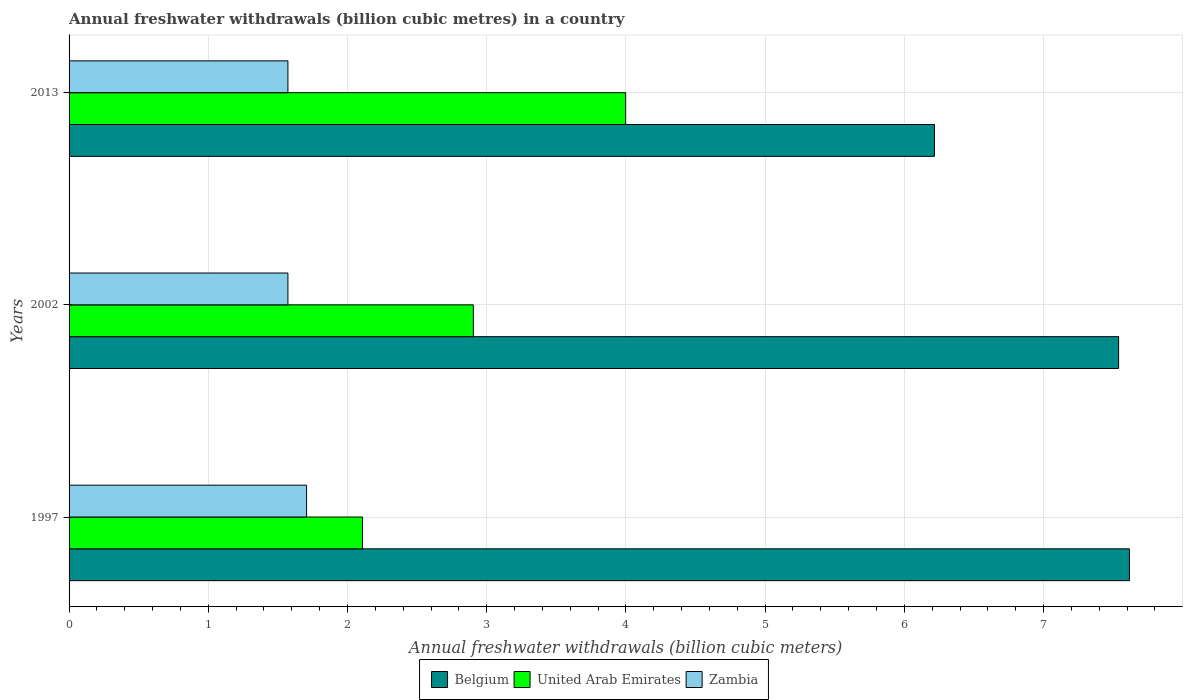How many groups of bars are there?
Make the answer very short. 3. How many bars are there on the 1st tick from the top?
Ensure brevity in your answer.  3. How many bars are there on the 2nd tick from the bottom?
Provide a short and direct response. 3. What is the label of the 1st group of bars from the top?
Ensure brevity in your answer.  2013. In how many cases, is the number of bars for a given year not equal to the number of legend labels?
Provide a short and direct response. 0. What is the annual freshwater withdrawals in United Arab Emirates in 2013?
Offer a terse response. 4. Across all years, what is the maximum annual freshwater withdrawals in Zambia?
Make the answer very short. 1.71. Across all years, what is the minimum annual freshwater withdrawals in Zambia?
Make the answer very short. 1.57. What is the total annual freshwater withdrawals in Zambia in the graph?
Make the answer very short. 4.85. What is the difference between the annual freshwater withdrawals in United Arab Emirates in 1997 and that in 2013?
Ensure brevity in your answer.  -1.89. What is the difference between the annual freshwater withdrawals in United Arab Emirates in 1997 and the annual freshwater withdrawals in Belgium in 2002?
Your response must be concise. -5.43. What is the average annual freshwater withdrawals in Zambia per year?
Offer a very short reply. 1.62. In the year 1997, what is the difference between the annual freshwater withdrawals in Zambia and annual freshwater withdrawals in United Arab Emirates?
Provide a succinct answer. -0.4. In how many years, is the annual freshwater withdrawals in Belgium greater than 2.2 billion cubic meters?
Ensure brevity in your answer.  3. What is the ratio of the annual freshwater withdrawals in Zambia in 2002 to that in 2013?
Offer a terse response. 1. Is the difference between the annual freshwater withdrawals in Zambia in 2002 and 2013 greater than the difference between the annual freshwater withdrawals in United Arab Emirates in 2002 and 2013?
Offer a very short reply. Yes. What is the difference between the highest and the second highest annual freshwater withdrawals in United Arab Emirates?
Offer a terse response. 1.09. What is the difference between the highest and the lowest annual freshwater withdrawals in Zambia?
Make the answer very short. 0.13. In how many years, is the annual freshwater withdrawals in Zambia greater than the average annual freshwater withdrawals in Zambia taken over all years?
Your response must be concise. 1. Is the sum of the annual freshwater withdrawals in Zambia in 1997 and 2002 greater than the maximum annual freshwater withdrawals in United Arab Emirates across all years?
Give a very brief answer. No. What does the 1st bar from the top in 1997 represents?
Make the answer very short. Zambia. What does the 1st bar from the bottom in 1997 represents?
Your answer should be very brief. Belgium. Is it the case that in every year, the sum of the annual freshwater withdrawals in Zambia and annual freshwater withdrawals in Belgium is greater than the annual freshwater withdrawals in United Arab Emirates?
Keep it short and to the point. Yes. How many bars are there?
Your response must be concise. 9. Where does the legend appear in the graph?
Your answer should be very brief. Bottom center. What is the title of the graph?
Provide a short and direct response. Annual freshwater withdrawals (billion cubic metres) in a country. What is the label or title of the X-axis?
Your answer should be very brief. Annual freshwater withdrawals (billion cubic meters). What is the Annual freshwater withdrawals (billion cubic meters) in Belgium in 1997?
Your response must be concise. 7.62. What is the Annual freshwater withdrawals (billion cubic meters) in United Arab Emirates in 1997?
Make the answer very short. 2.11. What is the Annual freshwater withdrawals (billion cubic meters) of Zambia in 1997?
Offer a terse response. 1.71. What is the Annual freshwater withdrawals (billion cubic meters) in Belgium in 2002?
Provide a short and direct response. 7.54. What is the Annual freshwater withdrawals (billion cubic meters) of United Arab Emirates in 2002?
Offer a very short reply. 2.9. What is the Annual freshwater withdrawals (billion cubic meters) of Zambia in 2002?
Keep it short and to the point. 1.57. What is the Annual freshwater withdrawals (billion cubic meters) of Belgium in 2013?
Offer a terse response. 6.22. What is the Annual freshwater withdrawals (billion cubic meters) of United Arab Emirates in 2013?
Offer a terse response. 4. What is the Annual freshwater withdrawals (billion cubic meters) of Zambia in 2013?
Give a very brief answer. 1.57. Across all years, what is the maximum Annual freshwater withdrawals (billion cubic meters) in Belgium?
Provide a short and direct response. 7.62. Across all years, what is the maximum Annual freshwater withdrawals (billion cubic meters) in United Arab Emirates?
Ensure brevity in your answer.  4. Across all years, what is the maximum Annual freshwater withdrawals (billion cubic meters) of Zambia?
Ensure brevity in your answer.  1.71. Across all years, what is the minimum Annual freshwater withdrawals (billion cubic meters) of Belgium?
Offer a very short reply. 6.22. Across all years, what is the minimum Annual freshwater withdrawals (billion cubic meters) in United Arab Emirates?
Give a very brief answer. 2.11. Across all years, what is the minimum Annual freshwater withdrawals (billion cubic meters) of Zambia?
Offer a terse response. 1.57. What is the total Annual freshwater withdrawals (billion cubic meters) of Belgium in the graph?
Your answer should be compact. 21.37. What is the total Annual freshwater withdrawals (billion cubic meters) in United Arab Emirates in the graph?
Keep it short and to the point. 9.01. What is the total Annual freshwater withdrawals (billion cubic meters) in Zambia in the graph?
Provide a succinct answer. 4.85. What is the difference between the Annual freshwater withdrawals (billion cubic meters) of Belgium in 1997 and that in 2002?
Make the answer very short. 0.08. What is the difference between the Annual freshwater withdrawals (billion cubic meters) of United Arab Emirates in 1997 and that in 2002?
Your answer should be very brief. -0.8. What is the difference between the Annual freshwater withdrawals (billion cubic meters) of Zambia in 1997 and that in 2002?
Provide a short and direct response. 0.13. What is the difference between the Annual freshwater withdrawals (billion cubic meters) of Belgium in 1997 and that in 2013?
Offer a very short reply. 1.4. What is the difference between the Annual freshwater withdrawals (billion cubic meters) in United Arab Emirates in 1997 and that in 2013?
Provide a short and direct response. -1.89. What is the difference between the Annual freshwater withdrawals (billion cubic meters) of Zambia in 1997 and that in 2013?
Provide a succinct answer. 0.13. What is the difference between the Annual freshwater withdrawals (billion cubic meters) in Belgium in 2002 and that in 2013?
Provide a short and direct response. 1.32. What is the difference between the Annual freshwater withdrawals (billion cubic meters) of United Arab Emirates in 2002 and that in 2013?
Make the answer very short. -1.09. What is the difference between the Annual freshwater withdrawals (billion cubic meters) in Zambia in 2002 and that in 2013?
Your answer should be compact. 0. What is the difference between the Annual freshwater withdrawals (billion cubic meters) of Belgium in 1997 and the Annual freshwater withdrawals (billion cubic meters) of United Arab Emirates in 2002?
Keep it short and to the point. 4.71. What is the difference between the Annual freshwater withdrawals (billion cubic meters) of Belgium in 1997 and the Annual freshwater withdrawals (billion cubic meters) of Zambia in 2002?
Offer a very short reply. 6.04. What is the difference between the Annual freshwater withdrawals (billion cubic meters) in United Arab Emirates in 1997 and the Annual freshwater withdrawals (billion cubic meters) in Zambia in 2002?
Keep it short and to the point. 0.54. What is the difference between the Annual freshwater withdrawals (billion cubic meters) of Belgium in 1997 and the Annual freshwater withdrawals (billion cubic meters) of United Arab Emirates in 2013?
Provide a short and direct response. 3.62. What is the difference between the Annual freshwater withdrawals (billion cubic meters) in Belgium in 1997 and the Annual freshwater withdrawals (billion cubic meters) in Zambia in 2013?
Ensure brevity in your answer.  6.04. What is the difference between the Annual freshwater withdrawals (billion cubic meters) of United Arab Emirates in 1997 and the Annual freshwater withdrawals (billion cubic meters) of Zambia in 2013?
Ensure brevity in your answer.  0.54. What is the difference between the Annual freshwater withdrawals (billion cubic meters) in Belgium in 2002 and the Annual freshwater withdrawals (billion cubic meters) in United Arab Emirates in 2013?
Make the answer very short. 3.54. What is the difference between the Annual freshwater withdrawals (billion cubic meters) of Belgium in 2002 and the Annual freshwater withdrawals (billion cubic meters) of Zambia in 2013?
Provide a short and direct response. 5.97. What is the difference between the Annual freshwater withdrawals (billion cubic meters) of United Arab Emirates in 2002 and the Annual freshwater withdrawals (billion cubic meters) of Zambia in 2013?
Provide a succinct answer. 1.33. What is the average Annual freshwater withdrawals (billion cubic meters) of Belgium per year?
Ensure brevity in your answer.  7.12. What is the average Annual freshwater withdrawals (billion cubic meters) in United Arab Emirates per year?
Your answer should be very brief. 3. What is the average Annual freshwater withdrawals (billion cubic meters) of Zambia per year?
Make the answer very short. 1.62. In the year 1997, what is the difference between the Annual freshwater withdrawals (billion cubic meters) in Belgium and Annual freshwater withdrawals (billion cubic meters) in United Arab Emirates?
Offer a very short reply. 5.51. In the year 1997, what is the difference between the Annual freshwater withdrawals (billion cubic meters) in Belgium and Annual freshwater withdrawals (billion cubic meters) in Zambia?
Offer a terse response. 5.91. In the year 1997, what is the difference between the Annual freshwater withdrawals (billion cubic meters) of United Arab Emirates and Annual freshwater withdrawals (billion cubic meters) of Zambia?
Ensure brevity in your answer.  0.4. In the year 2002, what is the difference between the Annual freshwater withdrawals (billion cubic meters) in Belgium and Annual freshwater withdrawals (billion cubic meters) in United Arab Emirates?
Give a very brief answer. 4.63. In the year 2002, what is the difference between the Annual freshwater withdrawals (billion cubic meters) in Belgium and Annual freshwater withdrawals (billion cubic meters) in Zambia?
Your response must be concise. 5.97. In the year 2002, what is the difference between the Annual freshwater withdrawals (billion cubic meters) in United Arab Emirates and Annual freshwater withdrawals (billion cubic meters) in Zambia?
Give a very brief answer. 1.33. In the year 2013, what is the difference between the Annual freshwater withdrawals (billion cubic meters) in Belgium and Annual freshwater withdrawals (billion cubic meters) in United Arab Emirates?
Your response must be concise. 2.22. In the year 2013, what is the difference between the Annual freshwater withdrawals (billion cubic meters) of Belgium and Annual freshwater withdrawals (billion cubic meters) of Zambia?
Your answer should be compact. 4.64. In the year 2013, what is the difference between the Annual freshwater withdrawals (billion cubic meters) of United Arab Emirates and Annual freshwater withdrawals (billion cubic meters) of Zambia?
Offer a very short reply. 2.43. What is the ratio of the Annual freshwater withdrawals (billion cubic meters) in Belgium in 1997 to that in 2002?
Provide a succinct answer. 1.01. What is the ratio of the Annual freshwater withdrawals (billion cubic meters) of United Arab Emirates in 1997 to that in 2002?
Provide a short and direct response. 0.73. What is the ratio of the Annual freshwater withdrawals (billion cubic meters) of Zambia in 1997 to that in 2002?
Provide a short and direct response. 1.09. What is the ratio of the Annual freshwater withdrawals (billion cubic meters) of Belgium in 1997 to that in 2013?
Provide a succinct answer. 1.23. What is the ratio of the Annual freshwater withdrawals (billion cubic meters) in United Arab Emirates in 1997 to that in 2013?
Give a very brief answer. 0.53. What is the ratio of the Annual freshwater withdrawals (billion cubic meters) in Zambia in 1997 to that in 2013?
Provide a short and direct response. 1.09. What is the ratio of the Annual freshwater withdrawals (billion cubic meters) in Belgium in 2002 to that in 2013?
Offer a terse response. 1.21. What is the ratio of the Annual freshwater withdrawals (billion cubic meters) of United Arab Emirates in 2002 to that in 2013?
Ensure brevity in your answer.  0.73. What is the difference between the highest and the second highest Annual freshwater withdrawals (billion cubic meters) in Belgium?
Your response must be concise. 0.08. What is the difference between the highest and the second highest Annual freshwater withdrawals (billion cubic meters) of United Arab Emirates?
Ensure brevity in your answer.  1.09. What is the difference between the highest and the second highest Annual freshwater withdrawals (billion cubic meters) in Zambia?
Your answer should be compact. 0.13. What is the difference between the highest and the lowest Annual freshwater withdrawals (billion cubic meters) in Belgium?
Give a very brief answer. 1.4. What is the difference between the highest and the lowest Annual freshwater withdrawals (billion cubic meters) of United Arab Emirates?
Ensure brevity in your answer.  1.89. What is the difference between the highest and the lowest Annual freshwater withdrawals (billion cubic meters) in Zambia?
Offer a very short reply. 0.13. 